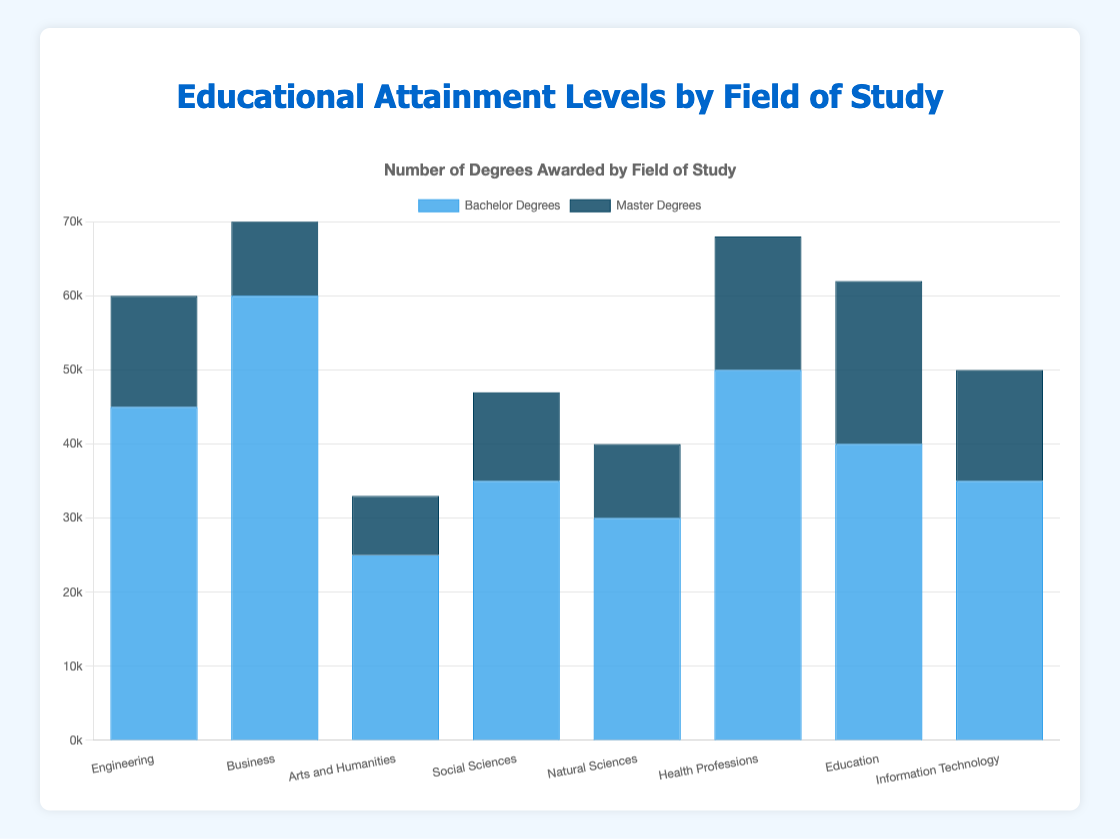Which field has the highest number of bachelor degrees awarded? Looking at the height of the blue bars in the bar chart, the field with the tallest blue bar represents the highest number of bachelor degrees awarded. Business has the tallest blue bar.
Answer: Business Which field has the lowest number of master degrees awarded? Observing the dark blue bars, the shortest dark blue bar indicates the field with the lowest number of master degrees awarded. Arts and Humanities has the shortest dark blue bar.
Answer: Arts and Humanities Between Engineering and Social Sciences, which field has more total degrees (bachelor and master combined)? Adding the numbers for bachelor and master degrees in each field: Engineering (45,000 + 15,000 = 60,000) and Social Sciences (35,000 + 12,000 = 47,000). Compare the totals to determine the higher one.
Answer: Engineering What is the average number of master degrees awarded across all fields? Sum the number of master degrees awarded in all fields and divide by the number of fields. The calculation is (15,000 + 20,000 + 8,000 + 12,000 + 10,000 + 18,000 + 22,000 + 15,000)/8 = 120,000/8 = 15,000.
Answer: 15,000 Which field has a greater difference between bachelor and master degrees awarded, Education or Health Professions? Calculate the difference for each field: Education (40,000 - 22,000 = 18,000) and Health Professions (50,000 - 18,000 = 32,000). Compare the differences to determine the greater one.
Answer: Health Professions Compare the total number of degrees (bachelor and master combined) for Information Technology and Natural Sciences. Which field has more total degrees? For Information Technology: 35,000 (bachelor) + 15,000 (master) = 50,000 and for Natural Sciences: 30,000 (bachelor) + 10,000 (master) = 40,000. Compare the totals.
Answer: Information Technology Based on the bar chart, which color represents master degrees? The dark blue color represents the master degrees, as observed from the legend and the bars.
Answer: Dark Blue How many more bachelor degrees were awarded in Business compared to Arts and Humanities? Subtract the number of bachelor degrees in Arts and Humanities from that in Business (60,000 - 25,000 = 35,000).
Answer: 35,000 Which field has an equal number of bachelor and master degrees awarded as Information Technology? Look for the field with the same number of degrees as Information Technology, which has 35,000 bachelor and 15,000 master degrees. Engineering also has 35,000 bachelor and 15,000 master degrees.
Answer: Engineering 